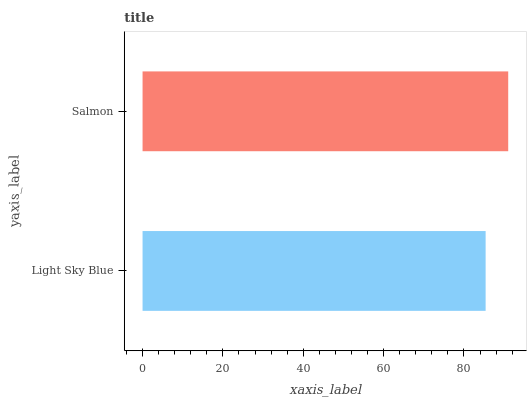Is Light Sky Blue the minimum?
Answer yes or no. Yes. Is Salmon the maximum?
Answer yes or no. Yes. Is Salmon the minimum?
Answer yes or no. No. Is Salmon greater than Light Sky Blue?
Answer yes or no. Yes. Is Light Sky Blue less than Salmon?
Answer yes or no. Yes. Is Light Sky Blue greater than Salmon?
Answer yes or no. No. Is Salmon less than Light Sky Blue?
Answer yes or no. No. Is Salmon the high median?
Answer yes or no. Yes. Is Light Sky Blue the low median?
Answer yes or no. Yes. Is Light Sky Blue the high median?
Answer yes or no. No. Is Salmon the low median?
Answer yes or no. No. 